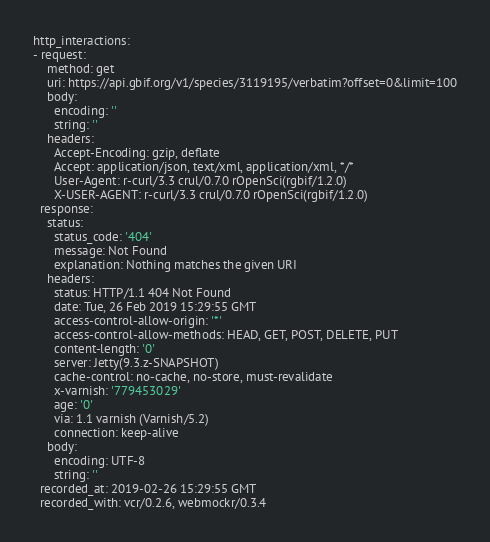Convert code to text. <code><loc_0><loc_0><loc_500><loc_500><_YAML_>http_interactions:
- request:
    method: get
    uri: https://api.gbif.org/v1/species/3119195/verbatim?offset=0&limit=100
    body:
      encoding: ''
      string: ''
    headers:
      Accept-Encoding: gzip, deflate
      Accept: application/json, text/xml, application/xml, */*
      User-Agent: r-curl/3.3 crul/0.7.0 rOpenSci(rgbif/1.2.0)
      X-USER-AGENT: r-curl/3.3 crul/0.7.0 rOpenSci(rgbif/1.2.0)
  response:
    status:
      status_code: '404'
      message: Not Found
      explanation: Nothing matches the given URI
    headers:
      status: HTTP/1.1 404 Not Found
      date: Tue, 26 Feb 2019 15:29:55 GMT
      access-control-allow-origin: '*'
      access-control-allow-methods: HEAD, GET, POST, DELETE, PUT
      content-length: '0'
      server: Jetty(9.3.z-SNAPSHOT)
      cache-control: no-cache, no-store, must-revalidate
      x-varnish: '779453029'
      age: '0'
      via: 1.1 varnish (Varnish/5.2)
      connection: keep-alive
    body:
      encoding: UTF-8
      string: ''
  recorded_at: 2019-02-26 15:29:55 GMT
  recorded_with: vcr/0.2.6, webmockr/0.3.4
</code> 